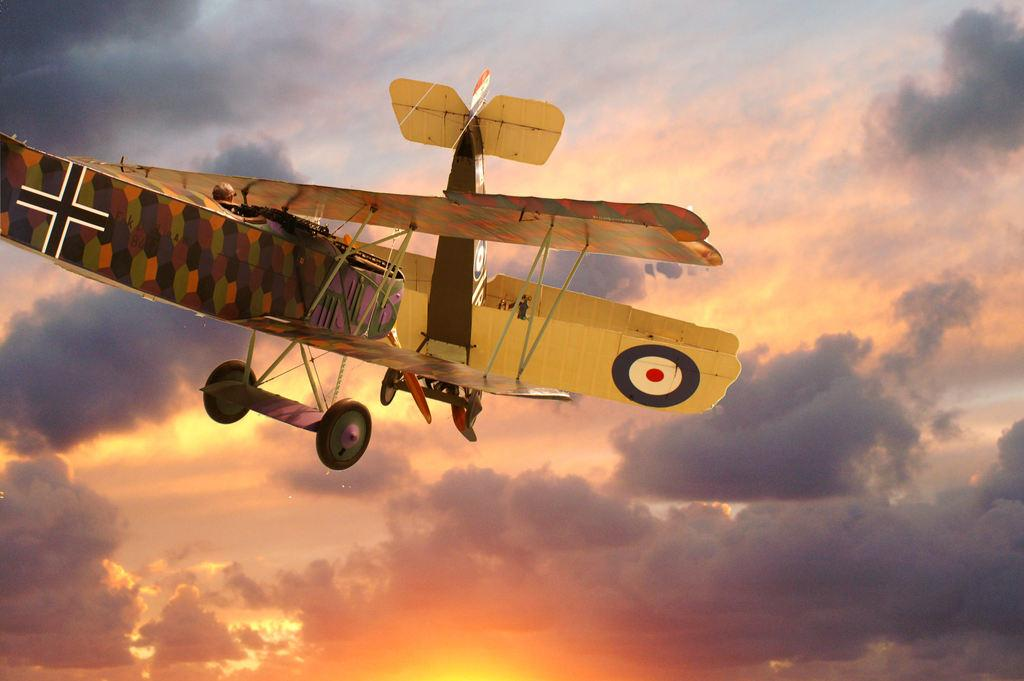What is the main subject of the image? The main subject of the image is an airplane. Can you describe the position of the airplane in the image? The airplane is in the air. What is the condition of the sky in the image? The sky is cloudy in the image. How many quarters can be seen on the wings of the airplane in the image? There are no quarters present on the wings of the airplane in the image. Are the dinosaurs flying alongside the airplane in the image? There are no dinosaurs present in the image. 